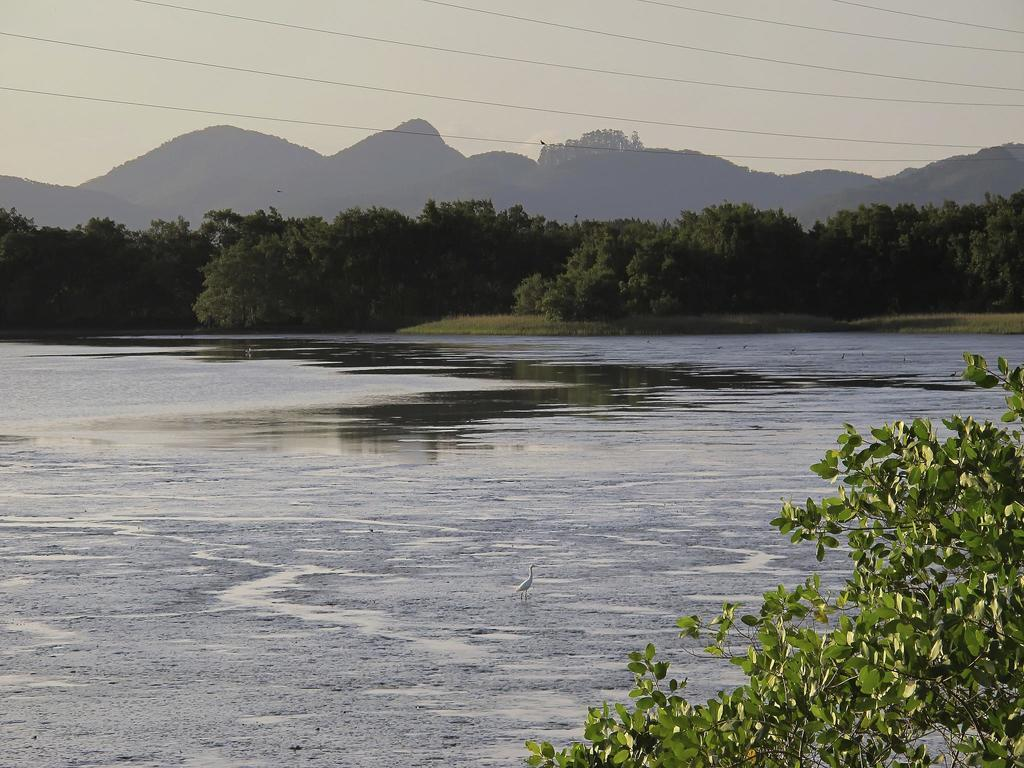What type of animal can be seen in the image? There is a bird in the image. What is the primary element in which the bird is situated? There is water visible in the image, and the bird is likely situated in or near it. What type of vegetation is present in the image? There are plants and trees in the image. What can be seen in the background of the image? There are hills and the sky visible in the background of the image. What does the fireman do in the image? There is no fireman present in the image. What emotion does the bird express towards the plants in the image? The image does not convey emotions, and it is not possible to determine the bird's feelings towards the plants. 